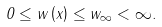Convert formula to latex. <formula><loc_0><loc_0><loc_500><loc_500>0 \leq w \left ( x \right ) \leq w _ { \infty } < \infty .</formula> 